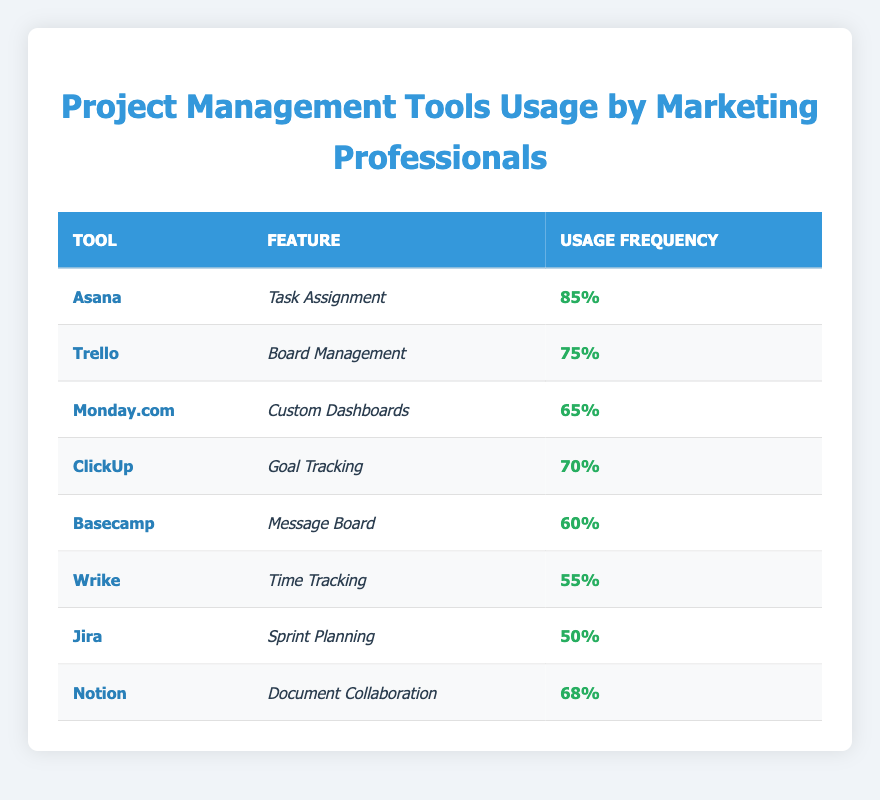What is the usage frequency percentage for Asana? The usage frequency percentage for Asana is listed directly in the table, which indicates 85%.
Answer: 85% Which project management tool has the lowest feature usage frequency? By examining the table, the tool with the lowest frequency usage percentage is Jira, with a value of 50%.
Answer: 50% What is the frequency usage percentage for Goal Tracking in ClickUp? The table specifies that Goal Tracking in ClickUp has a frequency usage percentage of 70%.
Answer: 70% What is the average frequency usage percentage of the tools listed? To calculate the average, we add all the frequency percentages together: (85 + 75 + 65 + 70 + 60 + 55 + 50 + 68) = 628. There are 8 tools, so the average is 628 divided by 8, resulting in 78.5.
Answer: 78.5 Is Basecamp used more frequently than Monday.com? The frequency usage for Basecamp is 60%, while for Monday.com it is 65%. Since 60 is less than 65, the answer is no, Basecamp is not used more frequently than Monday.com.
Answer: No Which feature has a higher usage frequency: Document Collaboration in Notion or Time Tracking in Wrike? Notion's Document Collaboration has a frequency of 68%, while Wrike's Time Tracking is 55%. Comparing these percentages clearly shows that 68% is greater than 55%. Thus, Document Collaboration has a higher usage frequency.
Answer: Document Collaboration What is the combined frequency usage percentage for Task Assignment and Board Management? The frequency for Task Assignment in Asana is 85% and for Board Management in Trello is 75%. To find the combined percentage, we add these two values: 85 + 75 = 160.
Answer: 160 Are marketing professionals more likely to use Trello or ClickUp for their project management needs? Trello's frequency usage percentage is 75%, while ClickUp's is 70%. Because 75% is greater than 70%, this indicates that marketing professionals are more likely to use Trello than ClickUp.
Answer: Yes How many tools have a usage frequency percentage of 60% or more? By reviewing the table, we identify that Asana (85%), Trello (75%), ClickUp (70%), Monday.com (65%), Basecamp (60%), and Notion (68%) all have a frequency usage percentage of 60% or more. Counting these tools gives us a total of 6.
Answer: 6 